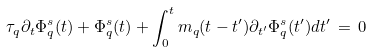Convert formula to latex. <formula><loc_0><loc_0><loc_500><loc_500>\tau _ { q } \partial _ { t } \Phi _ { q } ^ { s } ( t ) + \Phi _ { q } ^ { s } ( t ) + \int _ { 0 } ^ { t } m _ { q } ( t - t ^ { \prime } ) \partial _ { t ^ { \prime } } \Phi _ { q } ^ { s } ( t ^ { \prime } ) d t ^ { \prime } \, = \, 0</formula> 